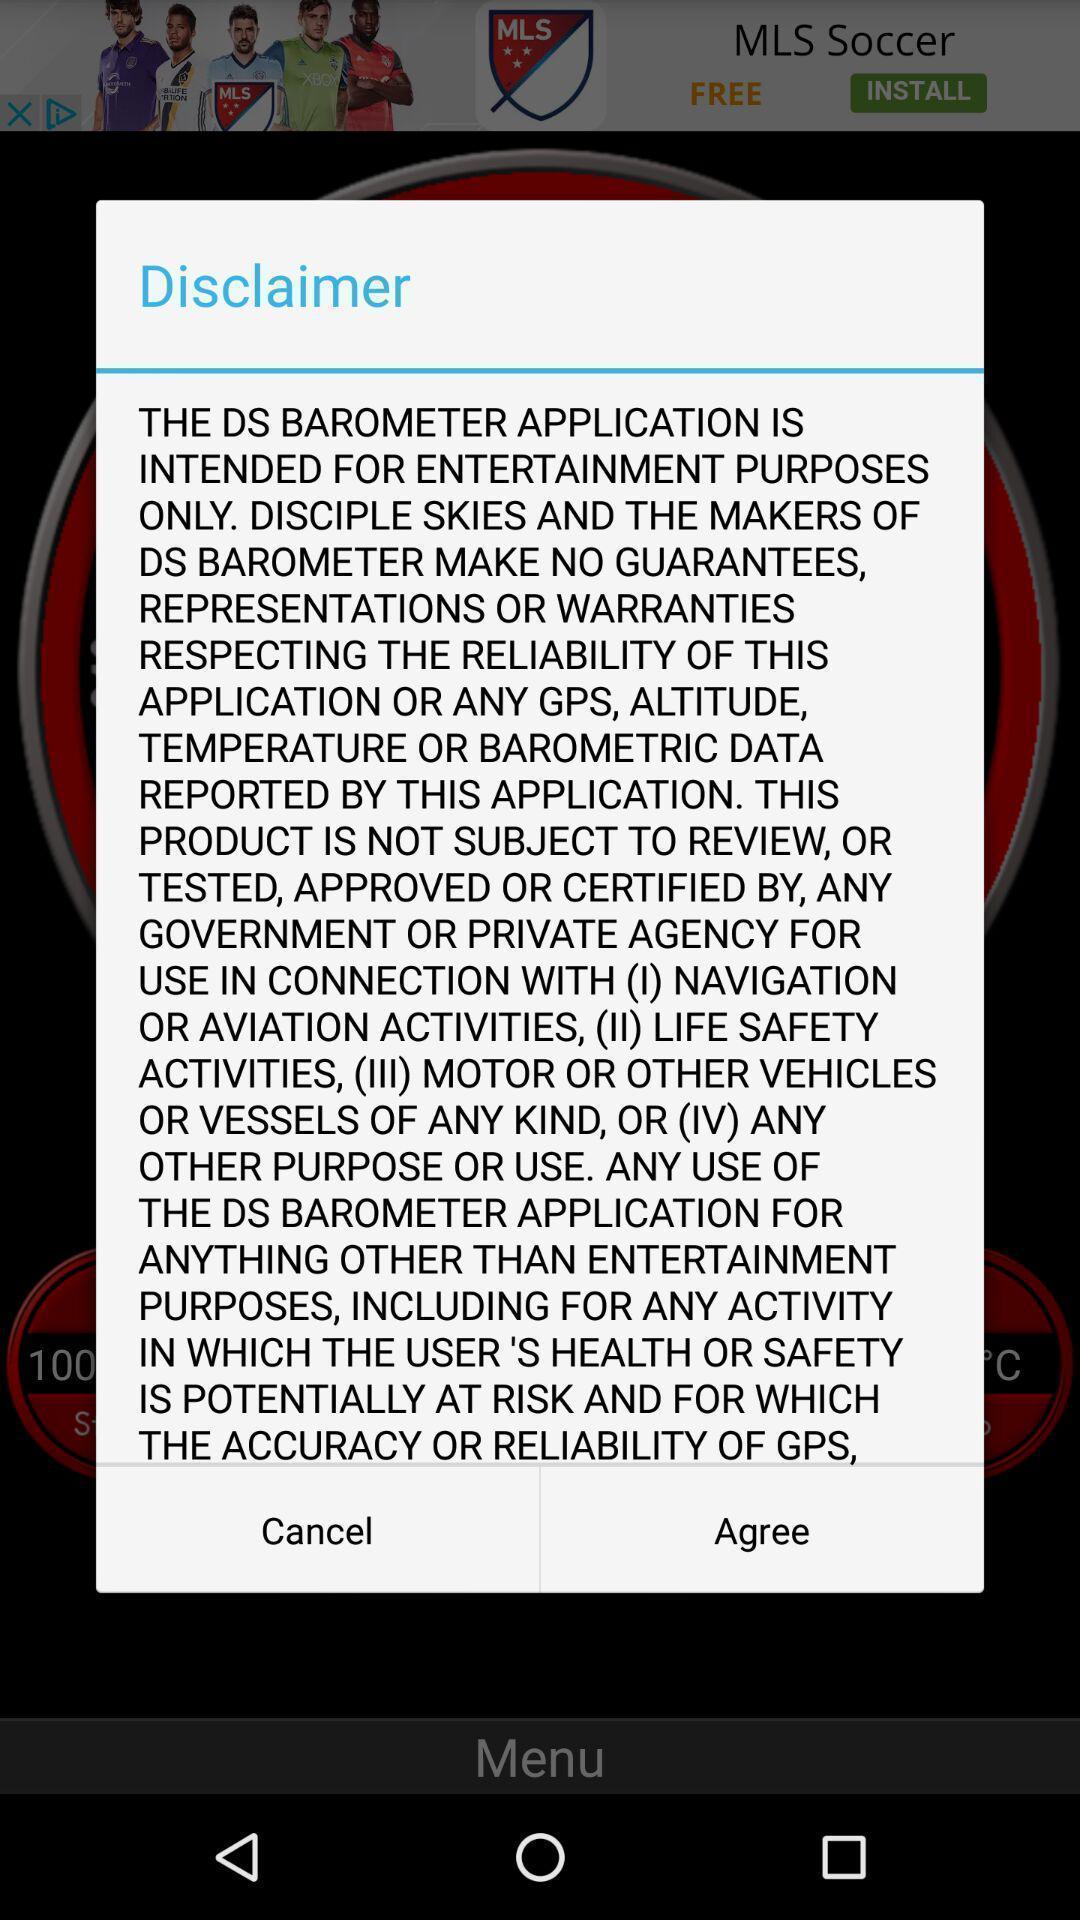Provide a detailed account of this screenshot. Pop-up displaying information about the application with few options. 